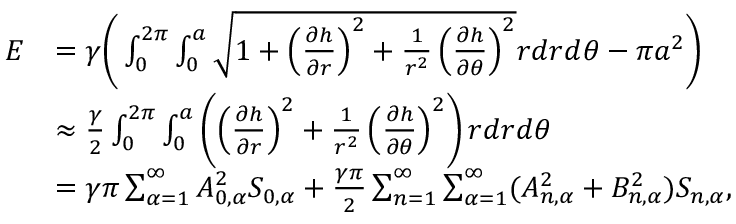Convert formula to latex. <formula><loc_0><loc_0><loc_500><loc_500>\begin{array} { r l } { E } & { = \gamma \left ( \int _ { 0 } ^ { 2 \pi } \int _ { 0 } ^ { a } \sqrt { 1 + \left ( \frac { \partial h } { \partial r } \right ) ^ { 2 } + \frac { 1 } { r ^ { 2 } } \left ( \frac { \partial h } { \partial \theta } \right ) ^ { 2 } } r d r d \theta - \pi a ^ { 2 } \right ) } \\ & { \approx \frac { \gamma } { 2 } \int _ { 0 } ^ { 2 \pi } \int _ { 0 } ^ { a } \left ( \left ( \frac { \partial h } { \partial r } \right ) ^ { 2 } + \frac { 1 } { r ^ { 2 } } \left ( \frac { \partial h } { \partial \theta } \right ) ^ { 2 } \right ) r d r d \theta } \\ & { = \gamma \pi \sum _ { \alpha = 1 } ^ { \infty } A _ { 0 , \alpha } ^ { 2 } S _ { 0 , \alpha } + \frac { \gamma \pi } { 2 } \sum _ { n = 1 } ^ { \infty } \sum _ { \alpha = 1 } ^ { \infty } ( A _ { n , \alpha } ^ { 2 } + B _ { n , \alpha } ^ { 2 } ) S _ { n , \alpha } , } \end{array}</formula> 